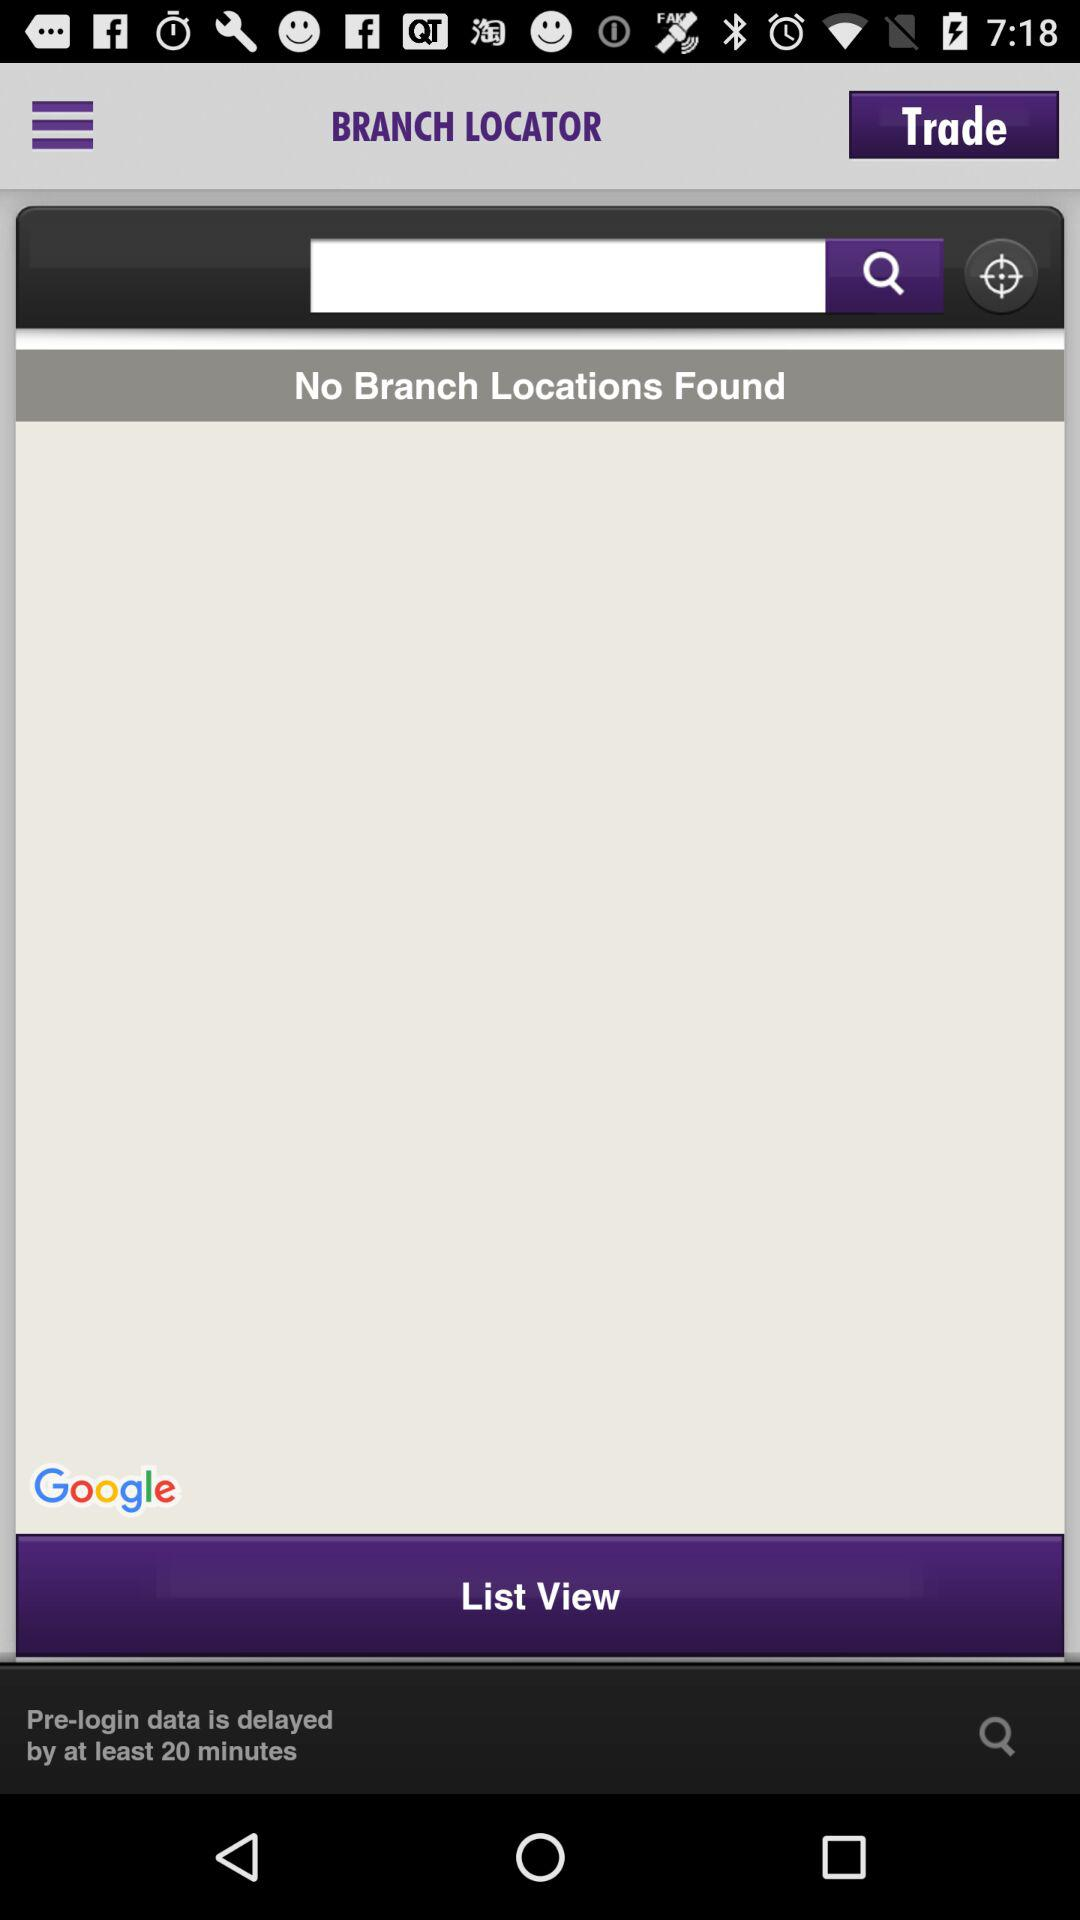What type of branch is being located?
When the provided information is insufficient, respond with <no answer>. <no answer> 